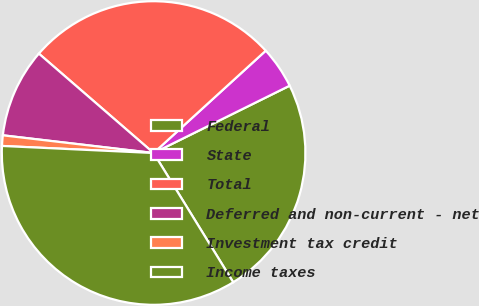<chart> <loc_0><loc_0><loc_500><loc_500><pie_chart><fcel>Federal<fcel>State<fcel>Total<fcel>Deferred and non-current - net<fcel>Investment tax credit<fcel>Income taxes<nl><fcel>23.53%<fcel>4.46%<fcel>26.87%<fcel>9.5%<fcel>1.12%<fcel>34.53%<nl></chart> 